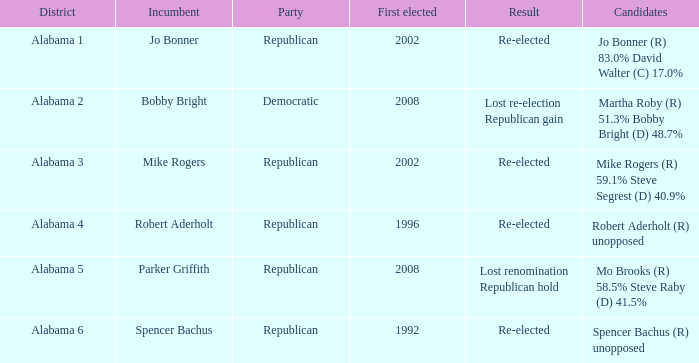Who is the current officeholder for the lost renomination republican hold? Parker Griffith. 